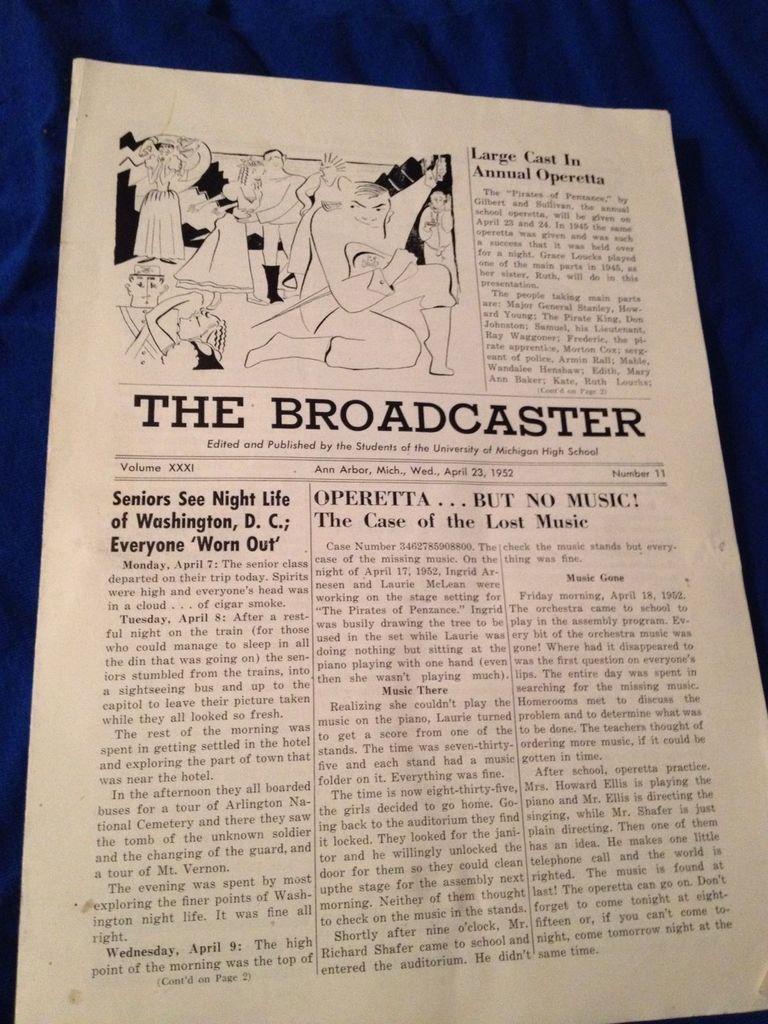What is the name of the newspaper?
Provide a short and direct response. The broadcaster. What year was this published?
Give a very brief answer. 1952. 